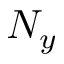Convert formula to latex. <formula><loc_0><loc_0><loc_500><loc_500>N _ { y }</formula> 